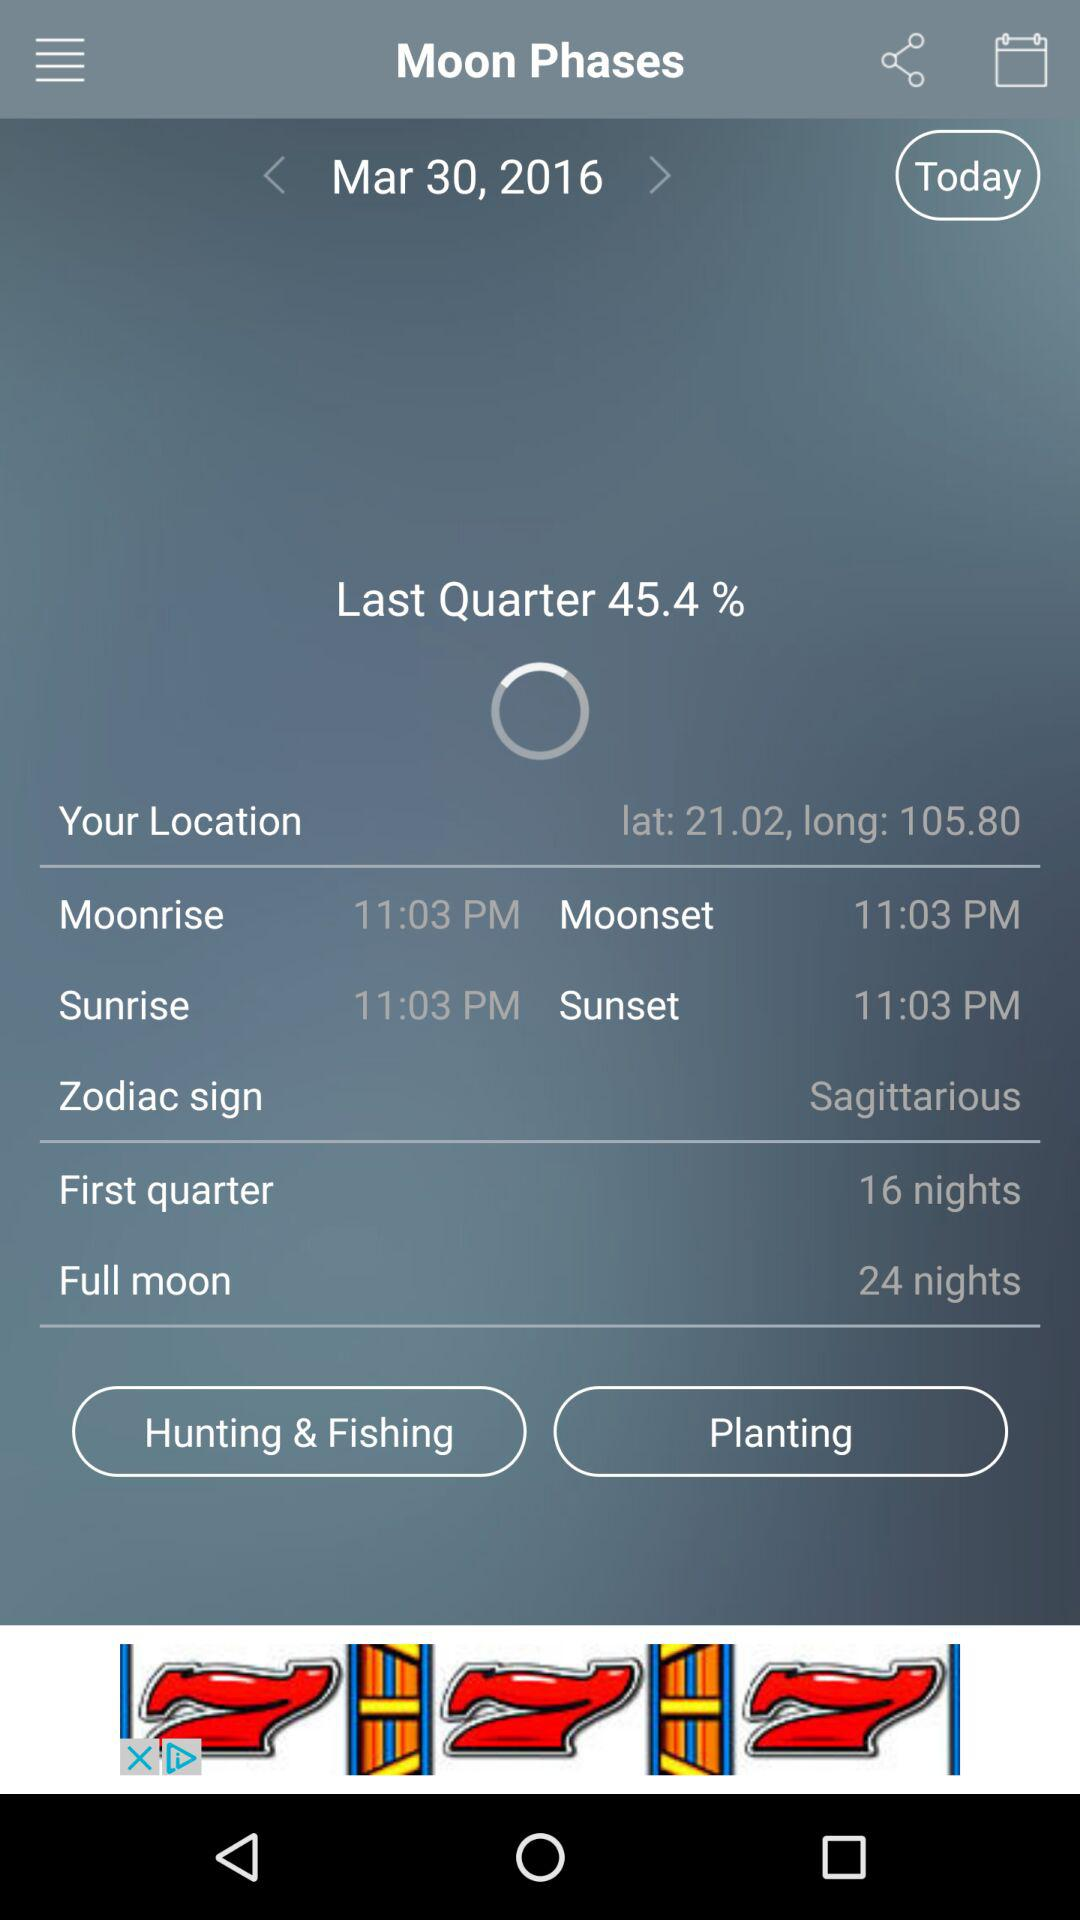What is the name of the zodiac sign that is currently in the sky?
Answer the question using a single word or phrase. Sagittarius 